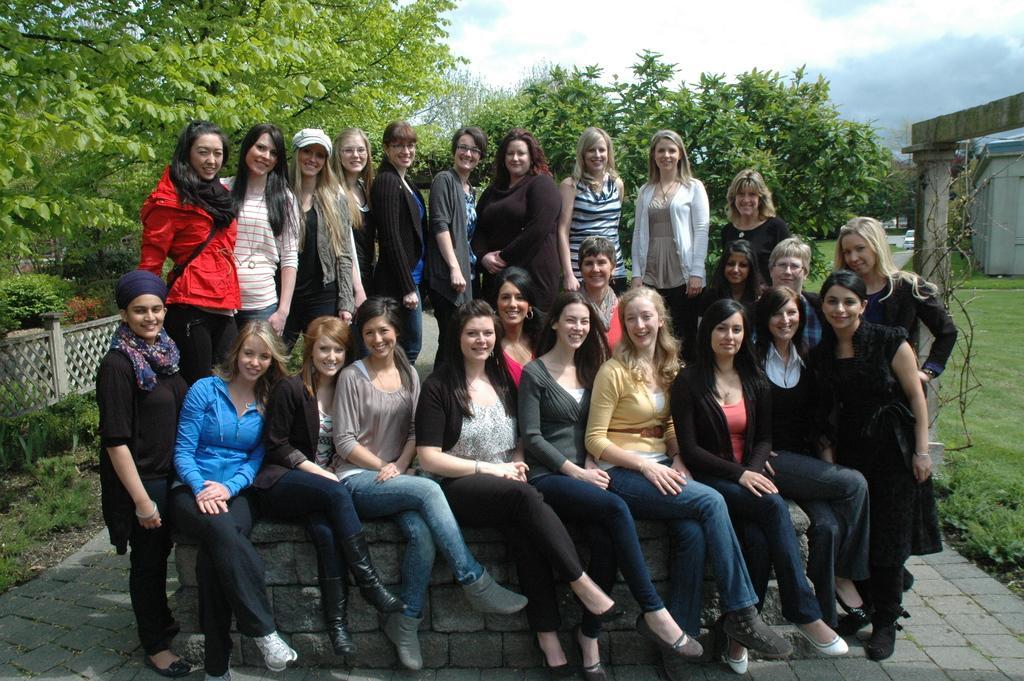In one or two sentences, can you explain what this image depicts? In this image there are a few people, they are posing with a smile to the camera. In the background of the image there are trees and sky. 